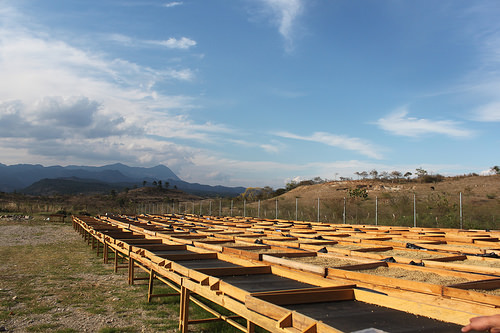<image>
Is the sky behind the fence? Yes. From this viewpoint, the sky is positioned behind the fence, with the fence partially or fully occluding the sky. 